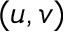<formula> <loc_0><loc_0><loc_500><loc_500>( u , v )</formula> 